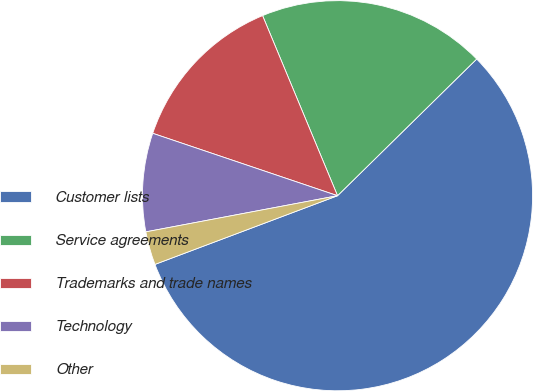Convert chart. <chart><loc_0><loc_0><loc_500><loc_500><pie_chart><fcel>Customer lists<fcel>Service agreements<fcel>Trademarks and trade names<fcel>Technology<fcel>Other<nl><fcel>56.63%<fcel>18.92%<fcel>13.54%<fcel>8.15%<fcel>2.76%<nl></chart> 